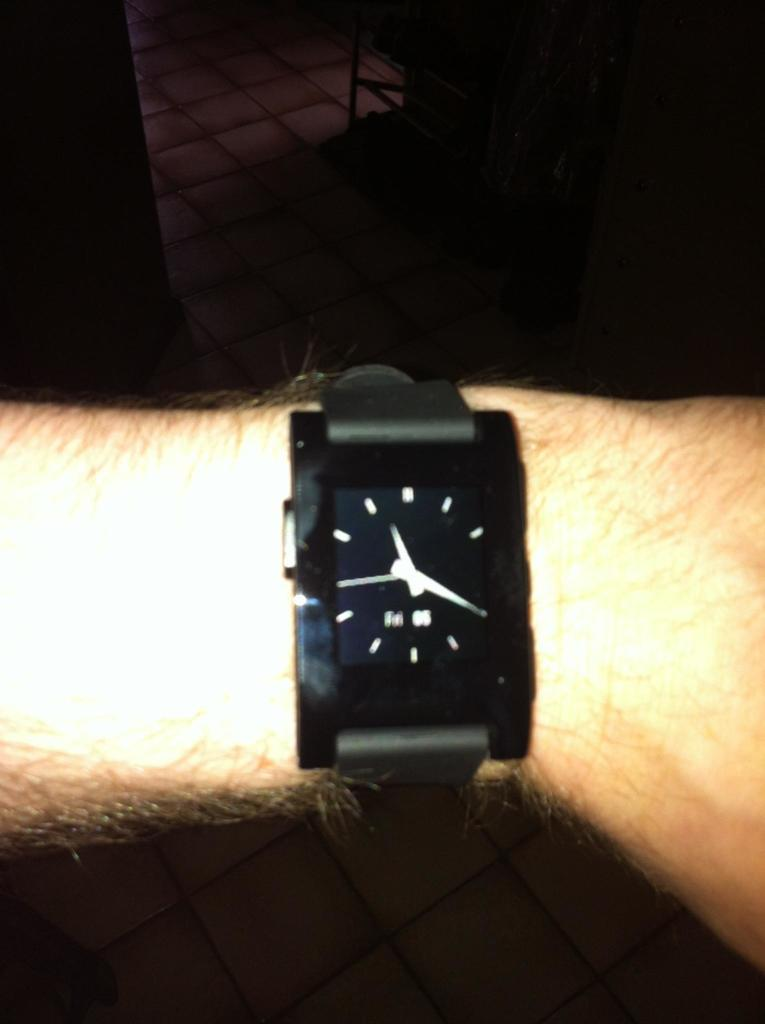What object is featured on a hand in the image? There is a watch in the image, and it is on a hand. What can be inferred about the lighting conditions in the image? The background of the image is dark, suggesting that the lighting is low or dim. What type of coat is being worn by the police officer in the cave in the image? There is no police officer, cave, or coat present in the image; it only features a watch on a hand with a dark background. 